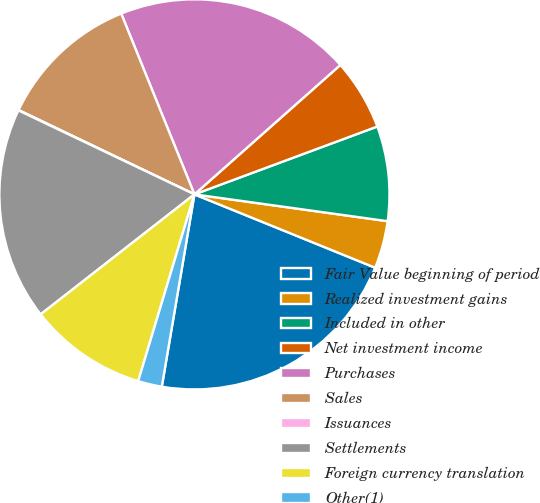<chart> <loc_0><loc_0><loc_500><loc_500><pie_chart><fcel>Fair Value beginning of period<fcel>Realized investment gains<fcel>Included in other<fcel>Net investment income<fcel>Purchases<fcel>Sales<fcel>Issuances<fcel>Settlements<fcel>Foreign currency translation<fcel>Other(1)<nl><fcel>21.54%<fcel>3.94%<fcel>7.85%<fcel>5.89%<fcel>19.58%<fcel>11.76%<fcel>0.03%<fcel>17.63%<fcel>9.8%<fcel>1.98%<nl></chart> 